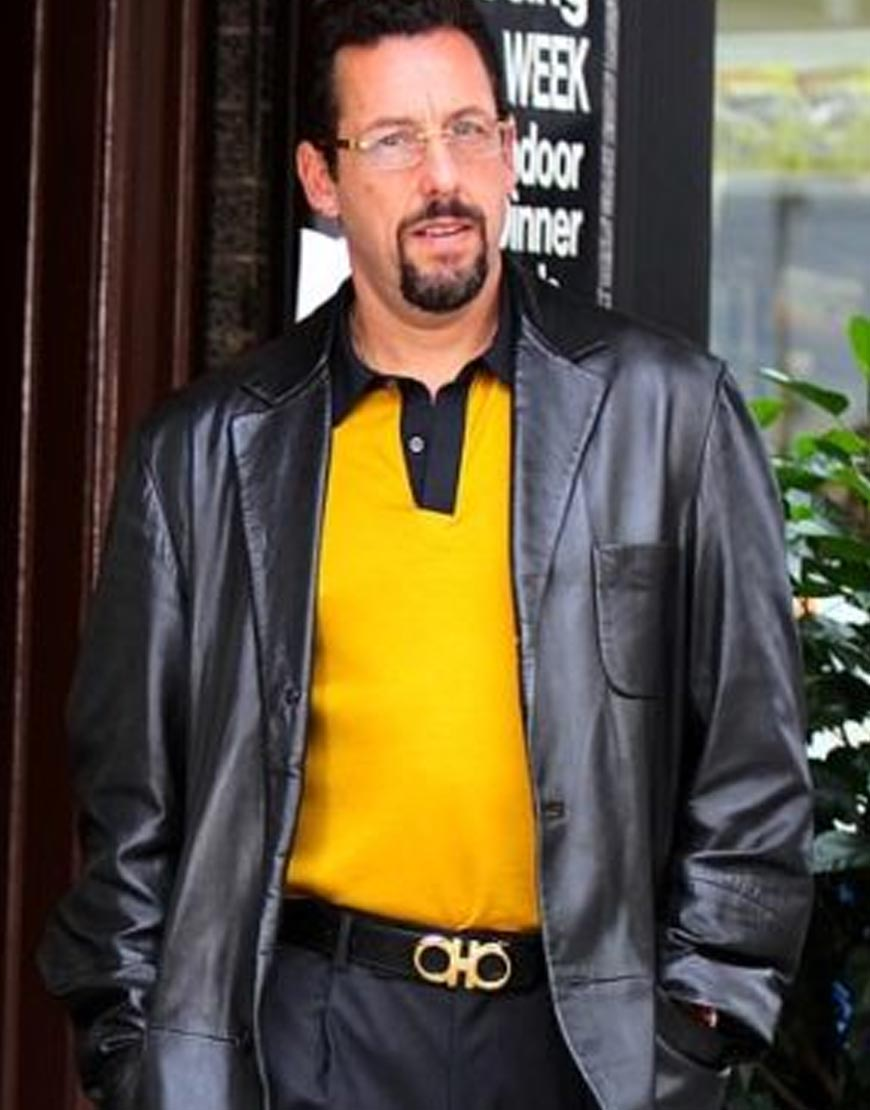If this man was a character in a movie, what genre would best suit his appearance? Given his sophisticated and slightly mysterious appearance, he would fit well in an action-thriller or spy movie. The combination of the sleek leather jacket and the cool, collected expression implies that he might play the role of a protagonist with a complex story—perhaps an undercover agent, a detective, or a vigilante with a secret identity. 